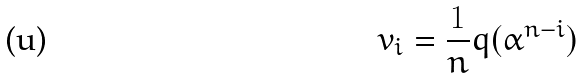<formula> <loc_0><loc_0><loc_500><loc_500>v _ { i } = \frac { 1 } { n } q ( \alpha ^ { n - i } )</formula> 